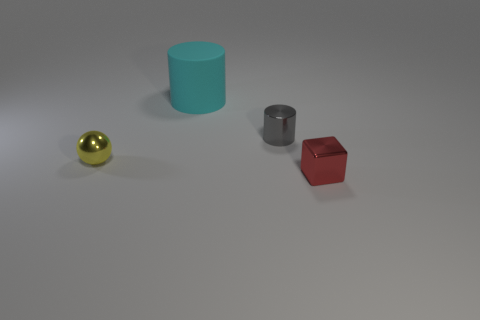How many other cyan matte objects have the same shape as the large rubber thing?
Keep it short and to the point. 0. There is a big matte thing; what shape is it?
Offer a terse response. Cylinder. There is a object that is behind the cylinder on the right side of the big cyan rubber thing; what size is it?
Your response must be concise. Large. What number of objects are brown cylinders or blocks?
Offer a terse response. 1. Does the big object have the same shape as the small gray shiny thing?
Offer a very short reply. Yes. Are there any blocks made of the same material as the yellow ball?
Give a very brief answer. Yes. Are there any metal things behind the metal object to the left of the tiny gray cylinder?
Your answer should be very brief. Yes. Does the metallic thing to the left of the cyan matte thing have the same size as the large cyan rubber cylinder?
Provide a succinct answer. No. How big is the yellow sphere?
Provide a short and direct response. Small. What number of tiny objects are red blocks or yellow metal cylinders?
Offer a very short reply. 1. 